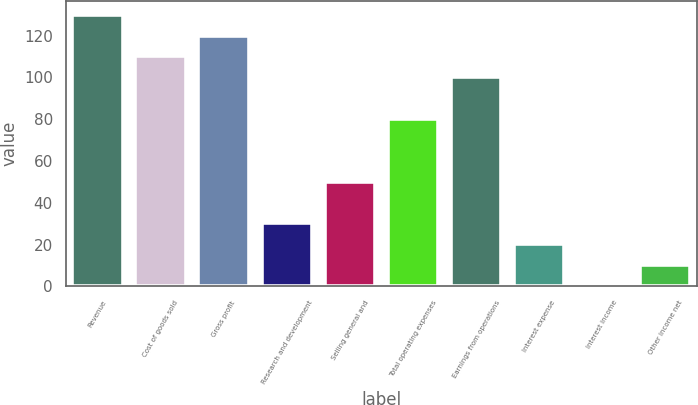Convert chart to OTSL. <chart><loc_0><loc_0><loc_500><loc_500><bar_chart><fcel>Revenue<fcel>Cost of goods sold<fcel>Gross profit<fcel>Research and development<fcel>Selling general and<fcel>Total operating expenses<fcel>Earnings from operations<fcel>Interest expense<fcel>Interest income<fcel>Other income net<nl><fcel>129.94<fcel>109.98<fcel>119.96<fcel>30.14<fcel>50.1<fcel>80.04<fcel>100<fcel>20.16<fcel>0.2<fcel>10.18<nl></chart> 